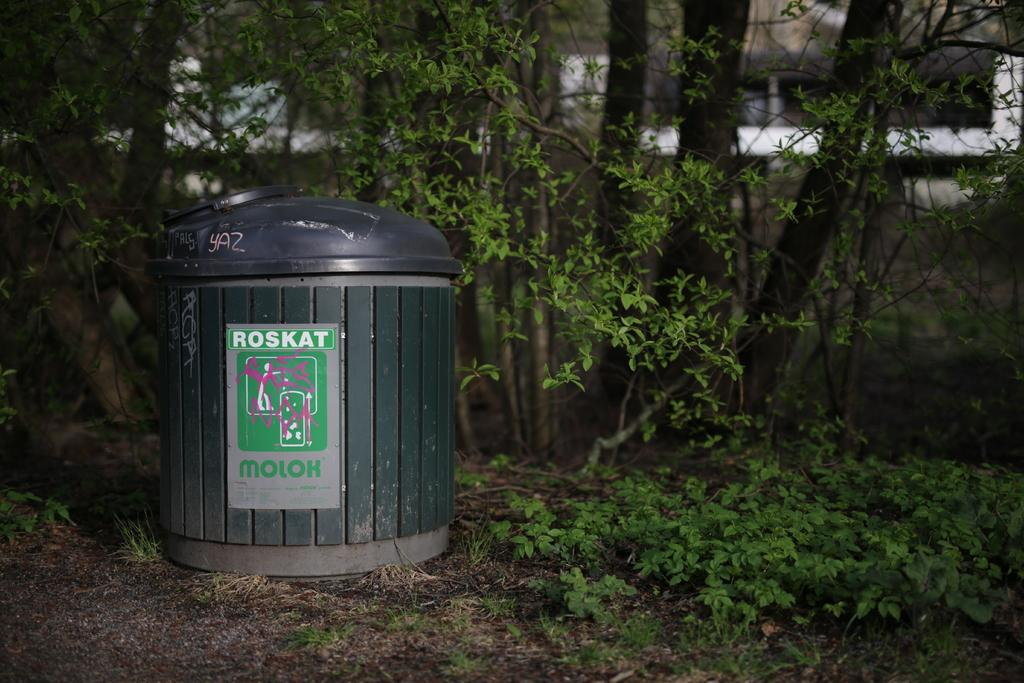<image>
Summarize the visual content of the image. A black trash can has the word Roskat in block white lettering. 